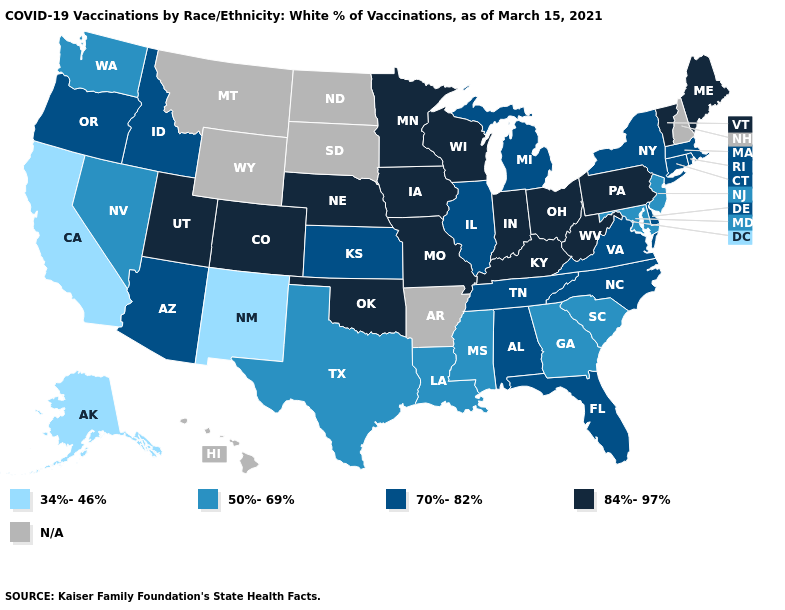What is the lowest value in the Northeast?
Write a very short answer. 50%-69%. Does Rhode Island have the lowest value in the Northeast?
Write a very short answer. No. Name the states that have a value in the range N/A?
Be succinct. Arkansas, Hawaii, Montana, New Hampshire, North Dakota, South Dakota, Wyoming. Which states have the highest value in the USA?
Concise answer only. Colorado, Indiana, Iowa, Kentucky, Maine, Minnesota, Missouri, Nebraska, Ohio, Oklahoma, Pennsylvania, Utah, Vermont, West Virginia, Wisconsin. What is the highest value in the USA?
Quick response, please. 84%-97%. Among the states that border North Carolina , does South Carolina have the highest value?
Answer briefly. No. What is the value of Arkansas?
Give a very brief answer. N/A. What is the value of Maryland?
Write a very short answer. 50%-69%. What is the highest value in the USA?
Keep it brief. 84%-97%. What is the lowest value in the West?
Quick response, please. 34%-46%. How many symbols are there in the legend?
Quick response, please. 5. Name the states that have a value in the range 84%-97%?
Give a very brief answer. Colorado, Indiana, Iowa, Kentucky, Maine, Minnesota, Missouri, Nebraska, Ohio, Oklahoma, Pennsylvania, Utah, Vermont, West Virginia, Wisconsin. How many symbols are there in the legend?
Answer briefly. 5. 